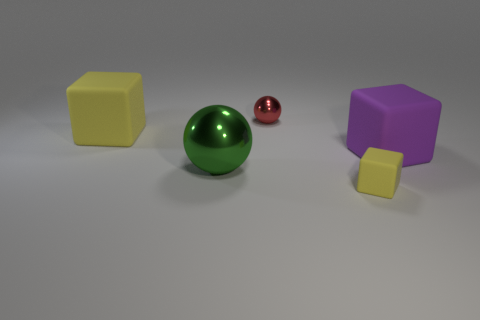There is another large thing that is made of the same material as the purple object; what is its shape? Besides the purple geometric shape in the image, which appears to be a cube, there is another large object made of a similar matte material. This object is a cube as well, with a yellow color, and like the purple object, it has distinctly flat and even surfaces with sharp edges. 